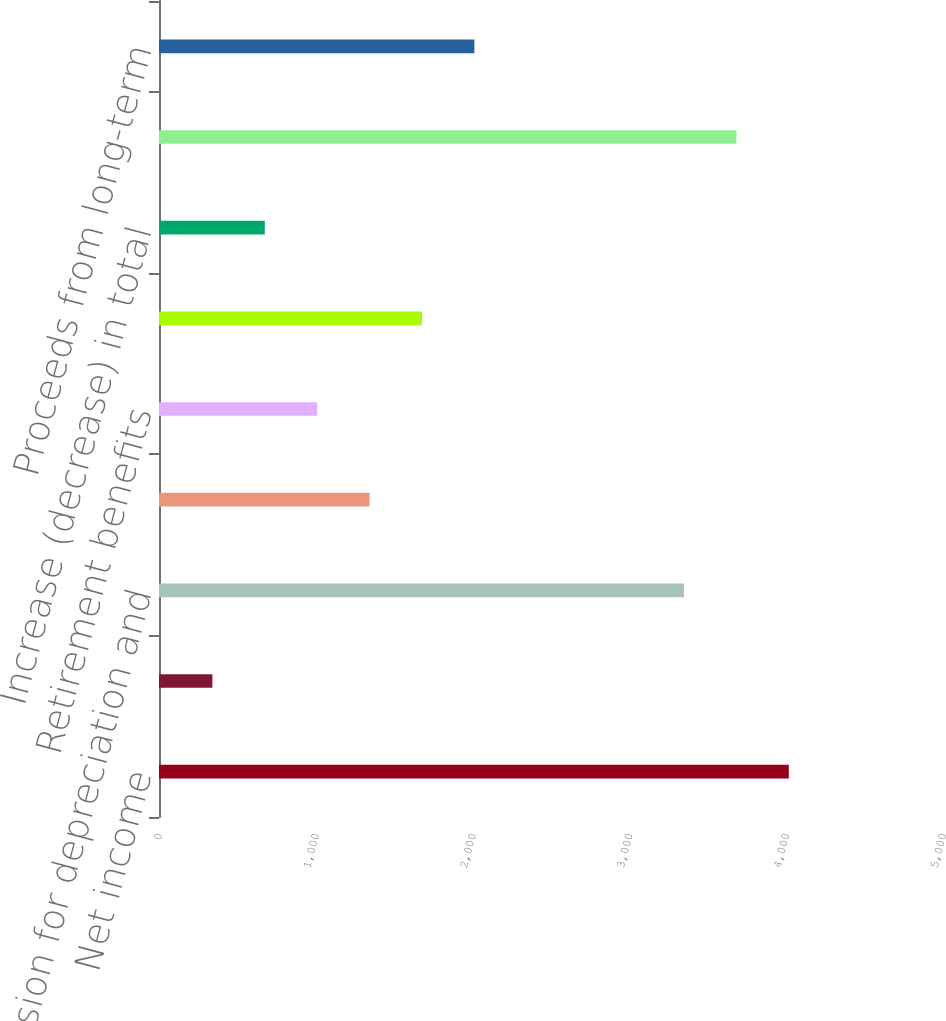Convert chart. <chart><loc_0><loc_0><loc_500><loc_500><bar_chart><fcel>Net income<fcel>Provision (credit) for<fcel>Provision for depreciation and<fcel>Undistributed earnings of<fcel>Retirement benefits<fcel>Other<fcel>Increase (decrease) in total<fcel>Change in intercompany<fcel>Proceeds from long-term<nl><fcel>4016.7<fcel>340.5<fcel>3348.3<fcel>1343.1<fcel>1008.9<fcel>1677.3<fcel>674.7<fcel>3682.5<fcel>2011.5<nl></chart> 